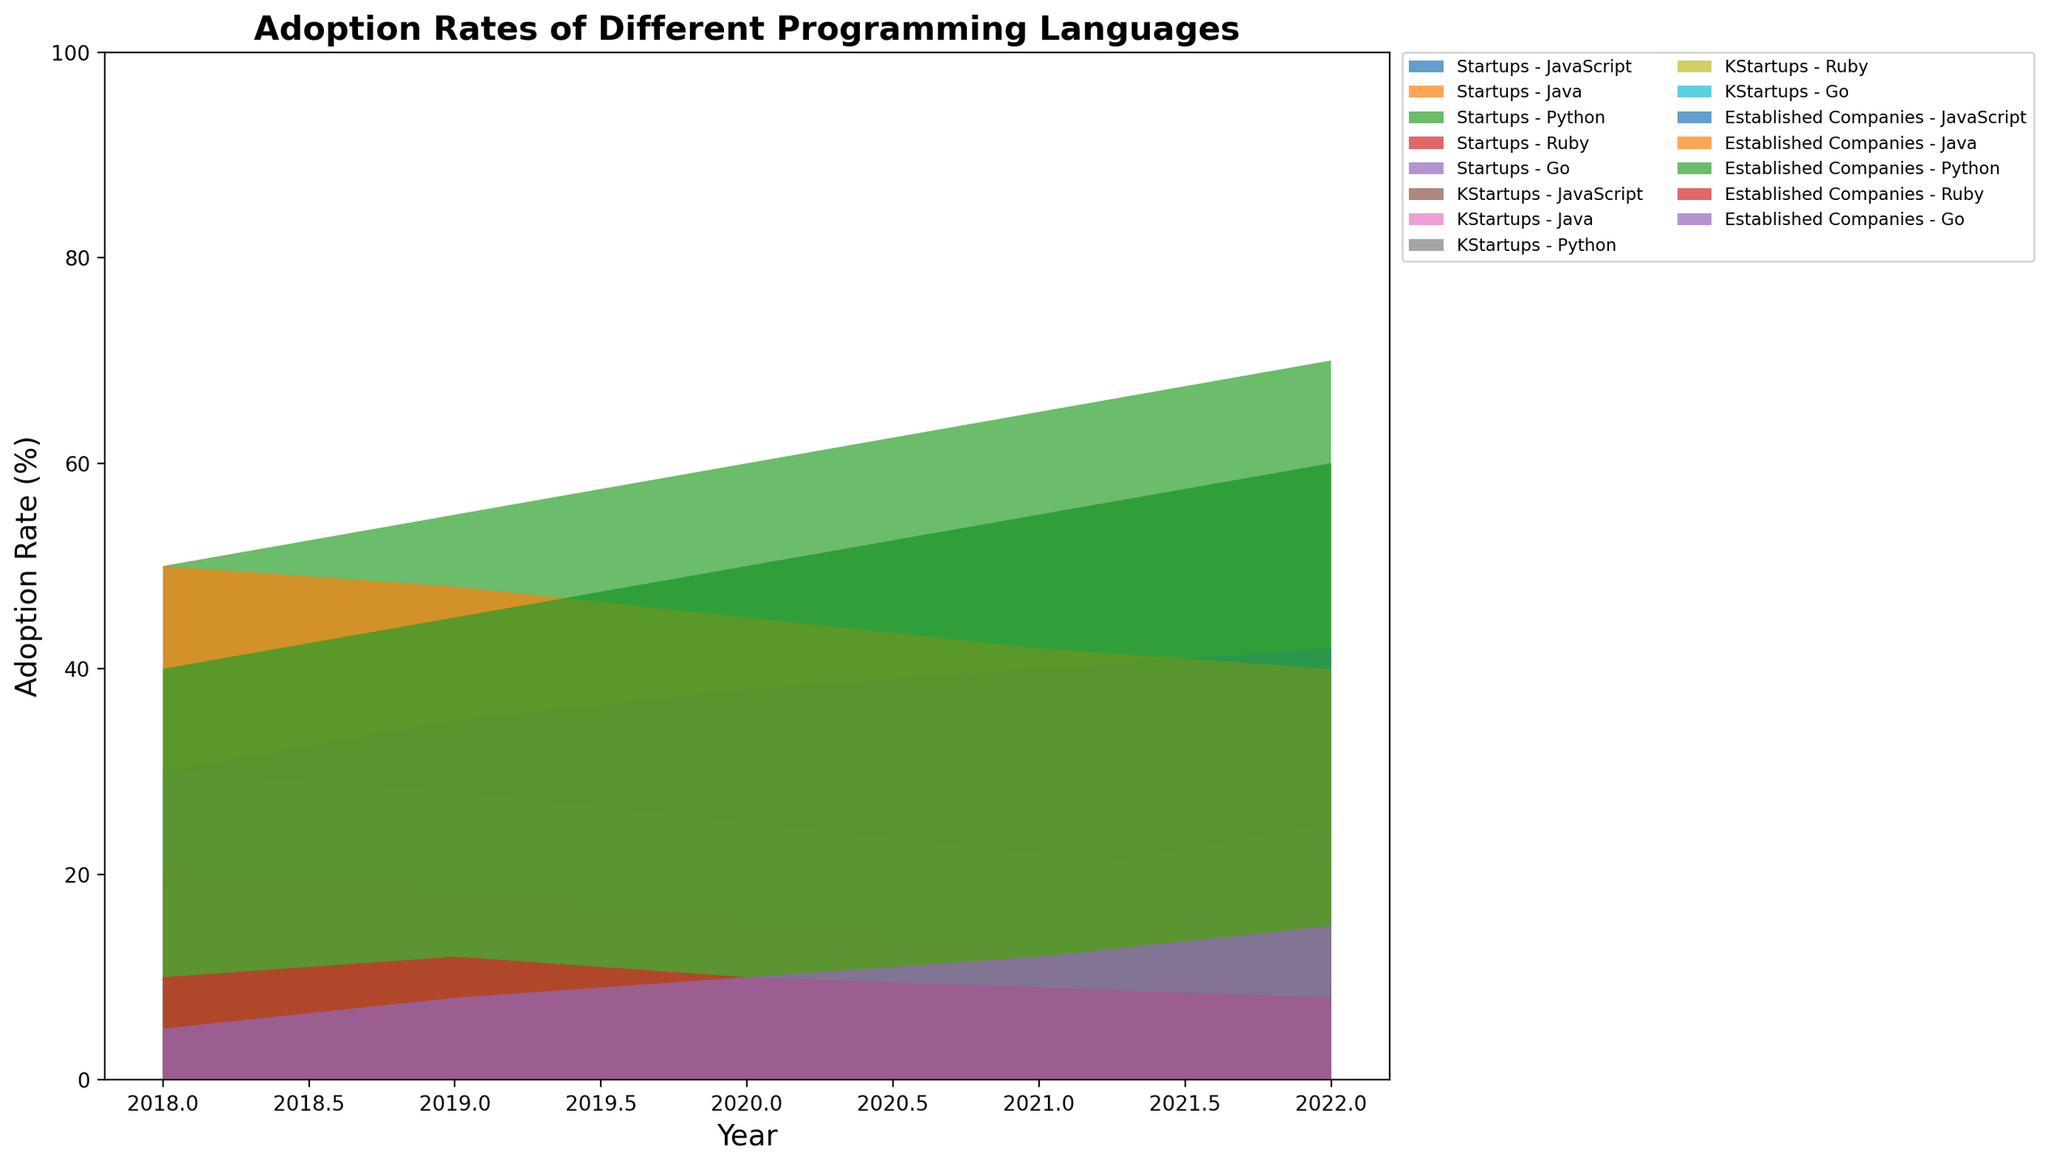what's the overall adoption trend for Python in Startups from 2018 to 2022? To determine the trend, we look at the Python adoption rates in Startups from 2018 to 2022: 50, 55, 60, 65, 70. The adoption rate increases each year, indicating a growing trend.
Answer: Increasing trend Which programming language had the highest adoption rate in Established Companies in 2022? By checking the adoption rates for all programming languages in Established Companies in 2022, Python has the highest adoption rate of 60%.
Answer: Python How did the adoption rate of JavaScript in Startups change from 2018 to 2022? Observing the adoption rates for JavaScript in Startups over the years: 40, 45, 50, 55, 60, we see a steady increase.
Answer: Increased steadily Did the adoption rates for Go in Established Companies show any significant change from 2018 to 2022? The adoption rates for Go in Established Companies over the years are: 5, 8, 10, 12, 15. The steady increase indicates significant growth.
Answer: Yes What's the average adoption rate for Ruby in Established Companies from 2018 to 2022? Adding up the adoption rates: 10, 12, 10, 9, 8, which totals to 49. There are 5 data points, so the average is 49/5 = 9.8%.
Answer: 9.8% Compare the adoption rate of Java in Startups vs. Established Companies in 2020. Which was higher? In 2020, the adoption rate for Java in Startups was 25%, whereas in Established Companies it was 45%. Therefore, the adoption rate in Established Companies was higher.
Answer: Established Companies In which year did Go first surpass a 10% adoption rate in Startups? The adoption rates for Go in Startups were: 10 (2018), 12 (2019), 15 (2020), 20 (2021), 25 (2022). The first year it surpasses 10% is 2019.
Answer: 2019 What's the difference in Python's adoption rate between Startups and Established Companies in 2021? In 2021, the adoption rate for Python was 65% in Startups and 55% in Established Companies. The difference is 65 - 55 = 10%.
Answer: 10% Which language showed the smallest change in adoption rates among Established Companies from 2018 to 2022? By comparing the change for each language in Established Companies: JavaScript (12%), Java (10%), Python (20%), Ruby (-2%), and Go (10%), Ruby showed the smallest change (+2%).
Answer: Ruby How did the adoption rate of Ruby in Startups change from 2018 to 2022? By looking at Ruby's adoption rates in Startups over the years: 20, 18, 15, 12, 10, we see a steady decrease.
Answer: Decreased steadily 